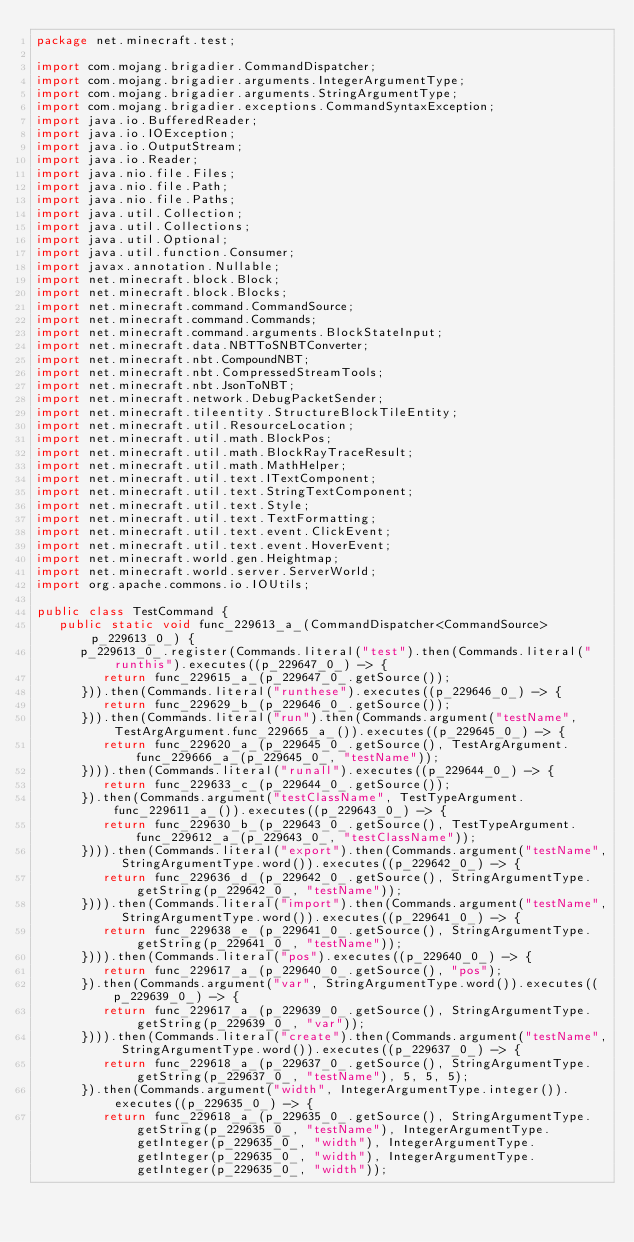<code> <loc_0><loc_0><loc_500><loc_500><_Java_>package net.minecraft.test;

import com.mojang.brigadier.CommandDispatcher;
import com.mojang.brigadier.arguments.IntegerArgumentType;
import com.mojang.brigadier.arguments.StringArgumentType;
import com.mojang.brigadier.exceptions.CommandSyntaxException;
import java.io.BufferedReader;
import java.io.IOException;
import java.io.OutputStream;
import java.io.Reader;
import java.nio.file.Files;
import java.nio.file.Path;
import java.nio.file.Paths;
import java.util.Collection;
import java.util.Collections;
import java.util.Optional;
import java.util.function.Consumer;
import javax.annotation.Nullable;
import net.minecraft.block.Block;
import net.minecraft.block.Blocks;
import net.minecraft.command.CommandSource;
import net.minecraft.command.Commands;
import net.minecraft.command.arguments.BlockStateInput;
import net.minecraft.data.NBTToSNBTConverter;
import net.minecraft.nbt.CompoundNBT;
import net.minecraft.nbt.CompressedStreamTools;
import net.minecraft.nbt.JsonToNBT;
import net.minecraft.network.DebugPacketSender;
import net.minecraft.tileentity.StructureBlockTileEntity;
import net.minecraft.util.ResourceLocation;
import net.minecraft.util.math.BlockPos;
import net.minecraft.util.math.BlockRayTraceResult;
import net.minecraft.util.math.MathHelper;
import net.minecraft.util.text.ITextComponent;
import net.minecraft.util.text.StringTextComponent;
import net.minecraft.util.text.Style;
import net.minecraft.util.text.TextFormatting;
import net.minecraft.util.text.event.ClickEvent;
import net.minecraft.util.text.event.HoverEvent;
import net.minecraft.world.gen.Heightmap;
import net.minecraft.world.server.ServerWorld;
import org.apache.commons.io.IOUtils;

public class TestCommand {
   public static void func_229613_a_(CommandDispatcher<CommandSource> p_229613_0_) {
      p_229613_0_.register(Commands.literal("test").then(Commands.literal("runthis").executes((p_229647_0_) -> {
         return func_229615_a_(p_229647_0_.getSource());
      })).then(Commands.literal("runthese").executes((p_229646_0_) -> {
         return func_229629_b_(p_229646_0_.getSource());
      })).then(Commands.literal("run").then(Commands.argument("testName", TestArgArgument.func_229665_a_()).executes((p_229645_0_) -> {
         return func_229620_a_(p_229645_0_.getSource(), TestArgArgument.func_229666_a_(p_229645_0_, "testName"));
      }))).then(Commands.literal("runall").executes((p_229644_0_) -> {
         return func_229633_c_(p_229644_0_.getSource());
      }).then(Commands.argument("testClassName", TestTypeArgument.func_229611_a_()).executes((p_229643_0_) -> {
         return func_229630_b_(p_229643_0_.getSource(), TestTypeArgument.func_229612_a_(p_229643_0_, "testClassName"));
      }))).then(Commands.literal("export").then(Commands.argument("testName", StringArgumentType.word()).executes((p_229642_0_) -> {
         return func_229636_d_(p_229642_0_.getSource(), StringArgumentType.getString(p_229642_0_, "testName"));
      }))).then(Commands.literal("import").then(Commands.argument("testName", StringArgumentType.word()).executes((p_229641_0_) -> {
         return func_229638_e_(p_229641_0_.getSource(), StringArgumentType.getString(p_229641_0_, "testName"));
      }))).then(Commands.literal("pos").executes((p_229640_0_) -> {
         return func_229617_a_(p_229640_0_.getSource(), "pos");
      }).then(Commands.argument("var", StringArgumentType.word()).executes((p_229639_0_) -> {
         return func_229617_a_(p_229639_0_.getSource(), StringArgumentType.getString(p_229639_0_, "var"));
      }))).then(Commands.literal("create").then(Commands.argument("testName", StringArgumentType.word()).executes((p_229637_0_) -> {
         return func_229618_a_(p_229637_0_.getSource(), StringArgumentType.getString(p_229637_0_, "testName"), 5, 5, 5);
      }).then(Commands.argument("width", IntegerArgumentType.integer()).executes((p_229635_0_) -> {
         return func_229618_a_(p_229635_0_.getSource(), StringArgumentType.getString(p_229635_0_, "testName"), IntegerArgumentType.getInteger(p_229635_0_, "width"), IntegerArgumentType.getInteger(p_229635_0_, "width"), IntegerArgumentType.getInteger(p_229635_0_, "width"));</code> 